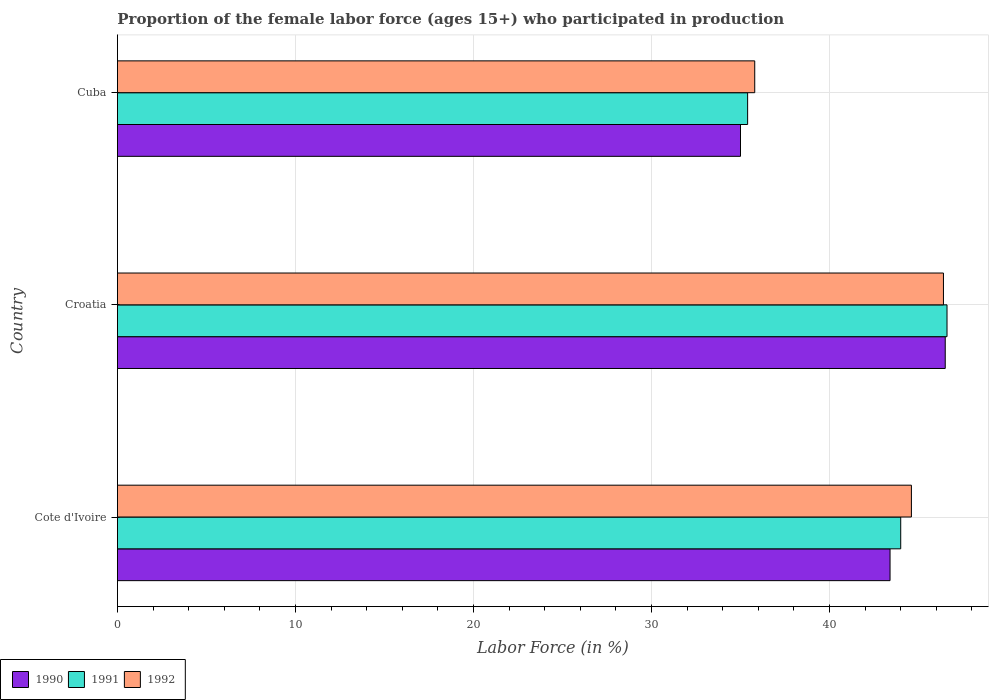How many groups of bars are there?
Provide a succinct answer. 3. Are the number of bars per tick equal to the number of legend labels?
Give a very brief answer. Yes. How many bars are there on the 3rd tick from the bottom?
Give a very brief answer. 3. What is the label of the 1st group of bars from the top?
Give a very brief answer. Cuba. In how many cases, is the number of bars for a given country not equal to the number of legend labels?
Your answer should be very brief. 0. What is the proportion of the female labor force who participated in production in 1992 in Cote d'Ivoire?
Offer a very short reply. 44.6. Across all countries, what is the maximum proportion of the female labor force who participated in production in 1990?
Ensure brevity in your answer.  46.5. Across all countries, what is the minimum proportion of the female labor force who participated in production in 1992?
Give a very brief answer. 35.8. In which country was the proportion of the female labor force who participated in production in 1991 maximum?
Your answer should be compact. Croatia. In which country was the proportion of the female labor force who participated in production in 1990 minimum?
Make the answer very short. Cuba. What is the total proportion of the female labor force who participated in production in 1990 in the graph?
Make the answer very short. 124.9. What is the difference between the proportion of the female labor force who participated in production in 1992 in Croatia and that in Cuba?
Keep it short and to the point. 10.6. What is the difference between the proportion of the female labor force who participated in production in 1991 in Croatia and the proportion of the female labor force who participated in production in 1992 in Cuba?
Your answer should be very brief. 10.8. What is the average proportion of the female labor force who participated in production in 1992 per country?
Keep it short and to the point. 42.27. What is the difference between the proportion of the female labor force who participated in production in 1992 and proportion of the female labor force who participated in production in 1990 in Cote d'Ivoire?
Your answer should be very brief. 1.2. In how many countries, is the proportion of the female labor force who participated in production in 1990 greater than 6 %?
Provide a short and direct response. 3. What is the ratio of the proportion of the female labor force who participated in production in 1992 in Cote d'Ivoire to that in Cuba?
Give a very brief answer. 1.25. Is the proportion of the female labor force who participated in production in 1991 in Cote d'Ivoire less than that in Cuba?
Your answer should be very brief. No. Is the difference between the proportion of the female labor force who participated in production in 1992 in Croatia and Cuba greater than the difference between the proportion of the female labor force who participated in production in 1990 in Croatia and Cuba?
Your answer should be compact. No. What is the difference between the highest and the second highest proportion of the female labor force who participated in production in 1992?
Your answer should be very brief. 1.8. What is the difference between the highest and the lowest proportion of the female labor force who participated in production in 1992?
Your answer should be very brief. 10.6. In how many countries, is the proportion of the female labor force who participated in production in 1991 greater than the average proportion of the female labor force who participated in production in 1991 taken over all countries?
Provide a succinct answer. 2. Is the sum of the proportion of the female labor force who participated in production in 1990 in Cote d'Ivoire and Croatia greater than the maximum proportion of the female labor force who participated in production in 1992 across all countries?
Your response must be concise. Yes. What does the 2nd bar from the top in Croatia represents?
Offer a very short reply. 1991. Are all the bars in the graph horizontal?
Ensure brevity in your answer.  Yes. How many countries are there in the graph?
Make the answer very short. 3. Are the values on the major ticks of X-axis written in scientific E-notation?
Offer a very short reply. No. Does the graph contain grids?
Offer a terse response. Yes. Where does the legend appear in the graph?
Give a very brief answer. Bottom left. How are the legend labels stacked?
Offer a terse response. Horizontal. What is the title of the graph?
Your answer should be compact. Proportion of the female labor force (ages 15+) who participated in production. Does "1996" appear as one of the legend labels in the graph?
Your answer should be very brief. No. What is the Labor Force (in %) in 1990 in Cote d'Ivoire?
Make the answer very short. 43.4. What is the Labor Force (in %) of 1992 in Cote d'Ivoire?
Offer a very short reply. 44.6. What is the Labor Force (in %) of 1990 in Croatia?
Offer a very short reply. 46.5. What is the Labor Force (in %) in 1991 in Croatia?
Your response must be concise. 46.6. What is the Labor Force (in %) in 1992 in Croatia?
Make the answer very short. 46.4. What is the Labor Force (in %) of 1990 in Cuba?
Ensure brevity in your answer.  35. What is the Labor Force (in %) in 1991 in Cuba?
Your answer should be compact. 35.4. What is the Labor Force (in %) of 1992 in Cuba?
Ensure brevity in your answer.  35.8. Across all countries, what is the maximum Labor Force (in %) of 1990?
Offer a very short reply. 46.5. Across all countries, what is the maximum Labor Force (in %) of 1991?
Offer a terse response. 46.6. Across all countries, what is the maximum Labor Force (in %) of 1992?
Offer a very short reply. 46.4. Across all countries, what is the minimum Labor Force (in %) of 1990?
Your answer should be very brief. 35. Across all countries, what is the minimum Labor Force (in %) in 1991?
Offer a very short reply. 35.4. Across all countries, what is the minimum Labor Force (in %) of 1992?
Your answer should be very brief. 35.8. What is the total Labor Force (in %) in 1990 in the graph?
Give a very brief answer. 124.9. What is the total Labor Force (in %) of 1991 in the graph?
Offer a terse response. 126. What is the total Labor Force (in %) of 1992 in the graph?
Ensure brevity in your answer.  126.8. What is the difference between the Labor Force (in %) in 1990 in Cote d'Ivoire and that in Croatia?
Provide a succinct answer. -3.1. What is the difference between the Labor Force (in %) of 1991 in Cote d'Ivoire and that in Croatia?
Your answer should be very brief. -2.6. What is the difference between the Labor Force (in %) in 1992 in Cote d'Ivoire and that in Croatia?
Ensure brevity in your answer.  -1.8. What is the difference between the Labor Force (in %) of 1990 in Cote d'Ivoire and that in Cuba?
Your answer should be compact. 8.4. What is the difference between the Labor Force (in %) in 1992 in Cote d'Ivoire and that in Cuba?
Give a very brief answer. 8.8. What is the difference between the Labor Force (in %) in 1990 in Cote d'Ivoire and the Labor Force (in %) in 1992 in Croatia?
Keep it short and to the point. -3. What is the difference between the Labor Force (in %) of 1991 in Cote d'Ivoire and the Labor Force (in %) of 1992 in Croatia?
Offer a very short reply. -2.4. What is the difference between the Labor Force (in %) of 1991 in Cote d'Ivoire and the Labor Force (in %) of 1992 in Cuba?
Offer a terse response. 8.2. What is the difference between the Labor Force (in %) in 1990 in Croatia and the Labor Force (in %) in 1991 in Cuba?
Your response must be concise. 11.1. What is the difference between the Labor Force (in %) of 1991 in Croatia and the Labor Force (in %) of 1992 in Cuba?
Ensure brevity in your answer.  10.8. What is the average Labor Force (in %) in 1990 per country?
Offer a terse response. 41.63. What is the average Labor Force (in %) in 1991 per country?
Ensure brevity in your answer.  42. What is the average Labor Force (in %) of 1992 per country?
Your response must be concise. 42.27. What is the difference between the Labor Force (in %) in 1990 and Labor Force (in %) in 1992 in Cote d'Ivoire?
Your response must be concise. -1.2. What is the difference between the Labor Force (in %) of 1990 and Labor Force (in %) of 1991 in Croatia?
Your answer should be compact. -0.1. What is the difference between the Labor Force (in %) in 1990 and Labor Force (in %) in 1992 in Croatia?
Your answer should be very brief. 0.1. What is the difference between the Labor Force (in %) of 1991 and Labor Force (in %) of 1992 in Croatia?
Give a very brief answer. 0.2. What is the difference between the Labor Force (in %) of 1990 and Labor Force (in %) of 1992 in Cuba?
Give a very brief answer. -0.8. What is the ratio of the Labor Force (in %) of 1991 in Cote d'Ivoire to that in Croatia?
Offer a terse response. 0.94. What is the ratio of the Labor Force (in %) in 1992 in Cote d'Ivoire to that in Croatia?
Provide a succinct answer. 0.96. What is the ratio of the Labor Force (in %) in 1990 in Cote d'Ivoire to that in Cuba?
Give a very brief answer. 1.24. What is the ratio of the Labor Force (in %) in 1991 in Cote d'Ivoire to that in Cuba?
Provide a short and direct response. 1.24. What is the ratio of the Labor Force (in %) of 1992 in Cote d'Ivoire to that in Cuba?
Offer a very short reply. 1.25. What is the ratio of the Labor Force (in %) of 1990 in Croatia to that in Cuba?
Your answer should be very brief. 1.33. What is the ratio of the Labor Force (in %) in 1991 in Croatia to that in Cuba?
Offer a terse response. 1.32. What is the ratio of the Labor Force (in %) of 1992 in Croatia to that in Cuba?
Your answer should be compact. 1.3. What is the difference between the highest and the second highest Labor Force (in %) of 1991?
Your answer should be compact. 2.6. What is the difference between the highest and the second highest Labor Force (in %) of 1992?
Provide a short and direct response. 1.8. What is the difference between the highest and the lowest Labor Force (in %) of 1990?
Give a very brief answer. 11.5. What is the difference between the highest and the lowest Labor Force (in %) of 1992?
Your answer should be very brief. 10.6. 